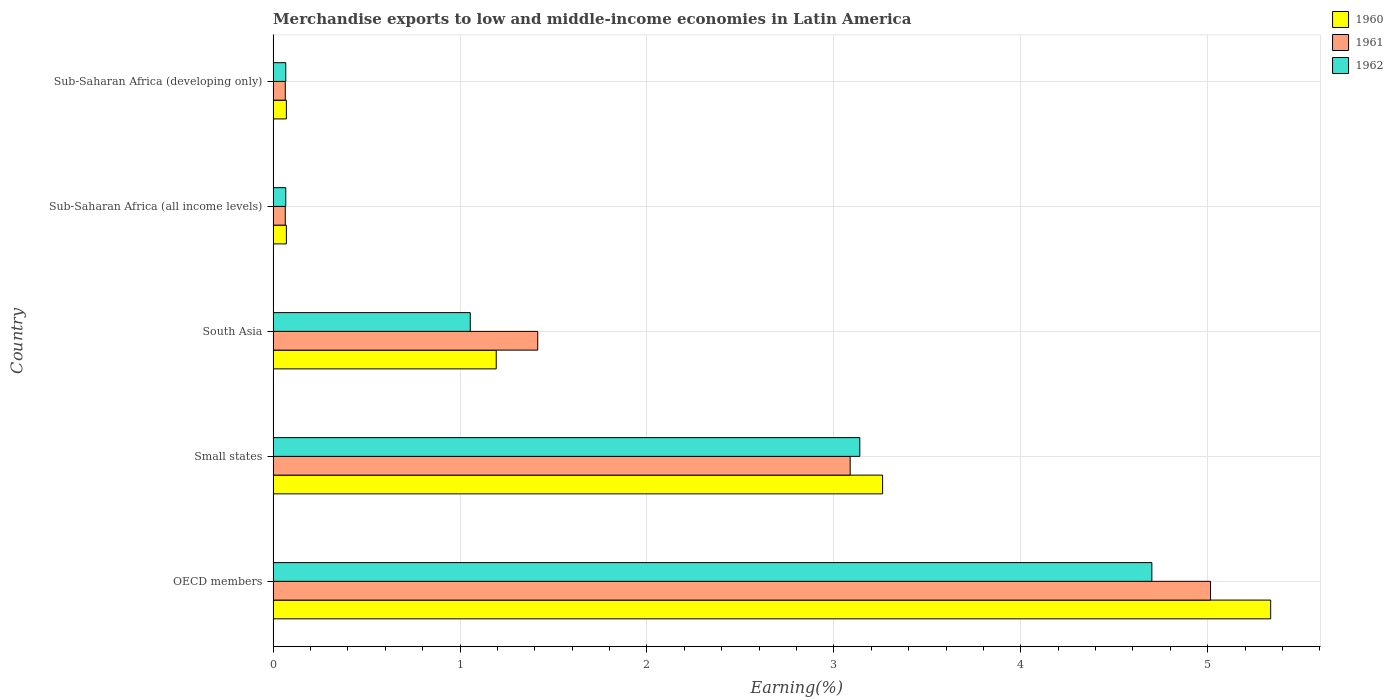How many different coloured bars are there?
Your response must be concise. 3. Are the number of bars per tick equal to the number of legend labels?
Your response must be concise. Yes. Are the number of bars on each tick of the Y-axis equal?
Your answer should be very brief. Yes. How many bars are there on the 4th tick from the top?
Make the answer very short. 3. What is the label of the 2nd group of bars from the top?
Your answer should be compact. Sub-Saharan Africa (all income levels). What is the percentage of amount earned from merchandise exports in 1961 in Small states?
Provide a short and direct response. 3.09. Across all countries, what is the maximum percentage of amount earned from merchandise exports in 1960?
Ensure brevity in your answer.  5.34. Across all countries, what is the minimum percentage of amount earned from merchandise exports in 1962?
Your response must be concise. 0.07. In which country was the percentage of amount earned from merchandise exports in 1962 minimum?
Offer a terse response. Sub-Saharan Africa (all income levels). What is the total percentage of amount earned from merchandise exports in 1961 in the graph?
Provide a short and direct response. 9.65. What is the difference between the percentage of amount earned from merchandise exports in 1961 in OECD members and that in Small states?
Offer a very short reply. 1.93. What is the difference between the percentage of amount earned from merchandise exports in 1962 in Sub-Saharan Africa (developing only) and the percentage of amount earned from merchandise exports in 1961 in Sub-Saharan Africa (all income levels)?
Offer a very short reply. 0. What is the average percentage of amount earned from merchandise exports in 1961 per country?
Provide a short and direct response. 1.93. What is the difference between the percentage of amount earned from merchandise exports in 1960 and percentage of amount earned from merchandise exports in 1961 in South Asia?
Your answer should be compact. -0.22. What is the ratio of the percentage of amount earned from merchandise exports in 1960 in Small states to that in Sub-Saharan Africa (all income levels)?
Ensure brevity in your answer.  46. What is the difference between the highest and the second highest percentage of amount earned from merchandise exports in 1961?
Your answer should be very brief. 1.93. What is the difference between the highest and the lowest percentage of amount earned from merchandise exports in 1961?
Your response must be concise. 4.95. In how many countries, is the percentage of amount earned from merchandise exports in 1961 greater than the average percentage of amount earned from merchandise exports in 1961 taken over all countries?
Your response must be concise. 2. Is the sum of the percentage of amount earned from merchandise exports in 1960 in OECD members and Small states greater than the maximum percentage of amount earned from merchandise exports in 1962 across all countries?
Keep it short and to the point. Yes. What does the 2nd bar from the top in Small states represents?
Your answer should be compact. 1961. Are all the bars in the graph horizontal?
Your answer should be compact. Yes. What is the difference between two consecutive major ticks on the X-axis?
Provide a short and direct response. 1. Are the values on the major ticks of X-axis written in scientific E-notation?
Give a very brief answer. No. Does the graph contain grids?
Provide a short and direct response. Yes. Where does the legend appear in the graph?
Your answer should be compact. Top right. How many legend labels are there?
Your answer should be compact. 3. How are the legend labels stacked?
Give a very brief answer. Vertical. What is the title of the graph?
Your answer should be very brief. Merchandise exports to low and middle-income economies in Latin America. What is the label or title of the X-axis?
Keep it short and to the point. Earning(%). What is the label or title of the Y-axis?
Provide a succinct answer. Country. What is the Earning(%) in 1960 in OECD members?
Make the answer very short. 5.34. What is the Earning(%) of 1961 in OECD members?
Offer a very short reply. 5.02. What is the Earning(%) in 1962 in OECD members?
Make the answer very short. 4.7. What is the Earning(%) in 1960 in Small states?
Give a very brief answer. 3.26. What is the Earning(%) in 1961 in Small states?
Ensure brevity in your answer.  3.09. What is the Earning(%) of 1962 in Small states?
Offer a terse response. 3.14. What is the Earning(%) in 1960 in South Asia?
Keep it short and to the point. 1.19. What is the Earning(%) of 1961 in South Asia?
Give a very brief answer. 1.42. What is the Earning(%) in 1962 in South Asia?
Your response must be concise. 1.05. What is the Earning(%) in 1960 in Sub-Saharan Africa (all income levels)?
Ensure brevity in your answer.  0.07. What is the Earning(%) in 1961 in Sub-Saharan Africa (all income levels)?
Make the answer very short. 0.07. What is the Earning(%) in 1962 in Sub-Saharan Africa (all income levels)?
Offer a terse response. 0.07. What is the Earning(%) of 1960 in Sub-Saharan Africa (developing only)?
Offer a very short reply. 0.07. What is the Earning(%) of 1961 in Sub-Saharan Africa (developing only)?
Keep it short and to the point. 0.07. What is the Earning(%) in 1962 in Sub-Saharan Africa (developing only)?
Keep it short and to the point. 0.07. Across all countries, what is the maximum Earning(%) in 1960?
Provide a succinct answer. 5.34. Across all countries, what is the maximum Earning(%) of 1961?
Offer a very short reply. 5.02. Across all countries, what is the maximum Earning(%) in 1962?
Provide a succinct answer. 4.7. Across all countries, what is the minimum Earning(%) of 1960?
Provide a short and direct response. 0.07. Across all countries, what is the minimum Earning(%) of 1961?
Your answer should be compact. 0.07. Across all countries, what is the minimum Earning(%) of 1962?
Provide a succinct answer. 0.07. What is the total Earning(%) of 1960 in the graph?
Provide a short and direct response. 9.93. What is the total Earning(%) in 1961 in the graph?
Offer a very short reply. 9.65. What is the total Earning(%) of 1962 in the graph?
Your answer should be very brief. 9.03. What is the difference between the Earning(%) of 1960 in OECD members and that in Small states?
Your answer should be compact. 2.08. What is the difference between the Earning(%) of 1961 in OECD members and that in Small states?
Your answer should be very brief. 1.93. What is the difference between the Earning(%) of 1962 in OECD members and that in Small states?
Keep it short and to the point. 1.56. What is the difference between the Earning(%) in 1960 in OECD members and that in South Asia?
Keep it short and to the point. 4.14. What is the difference between the Earning(%) of 1961 in OECD members and that in South Asia?
Provide a succinct answer. 3.6. What is the difference between the Earning(%) of 1962 in OECD members and that in South Asia?
Your response must be concise. 3.65. What is the difference between the Earning(%) of 1960 in OECD members and that in Sub-Saharan Africa (all income levels)?
Ensure brevity in your answer.  5.27. What is the difference between the Earning(%) in 1961 in OECD members and that in Sub-Saharan Africa (all income levels)?
Give a very brief answer. 4.95. What is the difference between the Earning(%) of 1962 in OECD members and that in Sub-Saharan Africa (all income levels)?
Your answer should be very brief. 4.63. What is the difference between the Earning(%) of 1960 in OECD members and that in Sub-Saharan Africa (developing only)?
Keep it short and to the point. 5.27. What is the difference between the Earning(%) of 1961 in OECD members and that in Sub-Saharan Africa (developing only)?
Offer a terse response. 4.95. What is the difference between the Earning(%) of 1962 in OECD members and that in Sub-Saharan Africa (developing only)?
Make the answer very short. 4.63. What is the difference between the Earning(%) in 1960 in Small states and that in South Asia?
Offer a terse response. 2.07. What is the difference between the Earning(%) of 1961 in Small states and that in South Asia?
Ensure brevity in your answer.  1.67. What is the difference between the Earning(%) in 1962 in Small states and that in South Asia?
Your answer should be very brief. 2.08. What is the difference between the Earning(%) in 1960 in Small states and that in Sub-Saharan Africa (all income levels)?
Provide a short and direct response. 3.19. What is the difference between the Earning(%) in 1961 in Small states and that in Sub-Saharan Africa (all income levels)?
Give a very brief answer. 3.02. What is the difference between the Earning(%) of 1962 in Small states and that in Sub-Saharan Africa (all income levels)?
Provide a succinct answer. 3.07. What is the difference between the Earning(%) of 1960 in Small states and that in Sub-Saharan Africa (developing only)?
Ensure brevity in your answer.  3.19. What is the difference between the Earning(%) in 1961 in Small states and that in Sub-Saharan Africa (developing only)?
Ensure brevity in your answer.  3.02. What is the difference between the Earning(%) of 1962 in Small states and that in Sub-Saharan Africa (developing only)?
Ensure brevity in your answer.  3.07. What is the difference between the Earning(%) in 1960 in South Asia and that in Sub-Saharan Africa (all income levels)?
Your response must be concise. 1.12. What is the difference between the Earning(%) of 1961 in South Asia and that in Sub-Saharan Africa (all income levels)?
Make the answer very short. 1.35. What is the difference between the Earning(%) of 1962 in South Asia and that in Sub-Saharan Africa (all income levels)?
Your answer should be compact. 0.99. What is the difference between the Earning(%) of 1960 in South Asia and that in Sub-Saharan Africa (developing only)?
Offer a terse response. 1.12. What is the difference between the Earning(%) in 1961 in South Asia and that in Sub-Saharan Africa (developing only)?
Ensure brevity in your answer.  1.35. What is the difference between the Earning(%) of 1962 in South Asia and that in Sub-Saharan Africa (developing only)?
Your answer should be very brief. 0.99. What is the difference between the Earning(%) of 1961 in Sub-Saharan Africa (all income levels) and that in Sub-Saharan Africa (developing only)?
Offer a very short reply. 0. What is the difference between the Earning(%) of 1962 in Sub-Saharan Africa (all income levels) and that in Sub-Saharan Africa (developing only)?
Keep it short and to the point. 0. What is the difference between the Earning(%) in 1960 in OECD members and the Earning(%) in 1961 in Small states?
Make the answer very short. 2.25. What is the difference between the Earning(%) in 1960 in OECD members and the Earning(%) in 1962 in Small states?
Offer a very short reply. 2.2. What is the difference between the Earning(%) in 1961 in OECD members and the Earning(%) in 1962 in Small states?
Give a very brief answer. 1.88. What is the difference between the Earning(%) in 1960 in OECD members and the Earning(%) in 1961 in South Asia?
Your answer should be very brief. 3.92. What is the difference between the Earning(%) in 1960 in OECD members and the Earning(%) in 1962 in South Asia?
Provide a succinct answer. 4.28. What is the difference between the Earning(%) of 1961 in OECD members and the Earning(%) of 1962 in South Asia?
Your answer should be very brief. 3.96. What is the difference between the Earning(%) in 1960 in OECD members and the Earning(%) in 1961 in Sub-Saharan Africa (all income levels)?
Your answer should be compact. 5.27. What is the difference between the Earning(%) in 1960 in OECD members and the Earning(%) in 1962 in Sub-Saharan Africa (all income levels)?
Provide a succinct answer. 5.27. What is the difference between the Earning(%) in 1961 in OECD members and the Earning(%) in 1962 in Sub-Saharan Africa (all income levels)?
Give a very brief answer. 4.95. What is the difference between the Earning(%) in 1960 in OECD members and the Earning(%) in 1961 in Sub-Saharan Africa (developing only)?
Make the answer very short. 5.27. What is the difference between the Earning(%) of 1960 in OECD members and the Earning(%) of 1962 in Sub-Saharan Africa (developing only)?
Make the answer very short. 5.27. What is the difference between the Earning(%) in 1961 in OECD members and the Earning(%) in 1962 in Sub-Saharan Africa (developing only)?
Offer a very short reply. 4.95. What is the difference between the Earning(%) of 1960 in Small states and the Earning(%) of 1961 in South Asia?
Your answer should be compact. 1.85. What is the difference between the Earning(%) of 1960 in Small states and the Earning(%) of 1962 in South Asia?
Provide a short and direct response. 2.21. What is the difference between the Earning(%) in 1961 in Small states and the Earning(%) in 1962 in South Asia?
Keep it short and to the point. 2.03. What is the difference between the Earning(%) of 1960 in Small states and the Earning(%) of 1961 in Sub-Saharan Africa (all income levels)?
Your answer should be compact. 3.2. What is the difference between the Earning(%) of 1960 in Small states and the Earning(%) of 1962 in Sub-Saharan Africa (all income levels)?
Make the answer very short. 3.19. What is the difference between the Earning(%) of 1961 in Small states and the Earning(%) of 1962 in Sub-Saharan Africa (all income levels)?
Make the answer very short. 3.02. What is the difference between the Earning(%) in 1960 in Small states and the Earning(%) in 1961 in Sub-Saharan Africa (developing only)?
Ensure brevity in your answer.  3.2. What is the difference between the Earning(%) of 1960 in Small states and the Earning(%) of 1962 in Sub-Saharan Africa (developing only)?
Your response must be concise. 3.19. What is the difference between the Earning(%) in 1961 in Small states and the Earning(%) in 1962 in Sub-Saharan Africa (developing only)?
Offer a terse response. 3.02. What is the difference between the Earning(%) in 1960 in South Asia and the Earning(%) in 1961 in Sub-Saharan Africa (all income levels)?
Ensure brevity in your answer.  1.13. What is the difference between the Earning(%) of 1960 in South Asia and the Earning(%) of 1962 in Sub-Saharan Africa (all income levels)?
Keep it short and to the point. 1.13. What is the difference between the Earning(%) in 1961 in South Asia and the Earning(%) in 1962 in Sub-Saharan Africa (all income levels)?
Ensure brevity in your answer.  1.35. What is the difference between the Earning(%) of 1960 in South Asia and the Earning(%) of 1961 in Sub-Saharan Africa (developing only)?
Provide a succinct answer. 1.13. What is the difference between the Earning(%) of 1960 in South Asia and the Earning(%) of 1962 in Sub-Saharan Africa (developing only)?
Provide a succinct answer. 1.13. What is the difference between the Earning(%) of 1961 in South Asia and the Earning(%) of 1962 in Sub-Saharan Africa (developing only)?
Offer a terse response. 1.35. What is the difference between the Earning(%) of 1960 in Sub-Saharan Africa (all income levels) and the Earning(%) of 1961 in Sub-Saharan Africa (developing only)?
Give a very brief answer. 0.01. What is the difference between the Earning(%) of 1960 in Sub-Saharan Africa (all income levels) and the Earning(%) of 1962 in Sub-Saharan Africa (developing only)?
Your response must be concise. 0. What is the difference between the Earning(%) in 1961 in Sub-Saharan Africa (all income levels) and the Earning(%) in 1962 in Sub-Saharan Africa (developing only)?
Offer a terse response. -0. What is the average Earning(%) of 1960 per country?
Provide a succinct answer. 1.99. What is the average Earning(%) of 1961 per country?
Provide a succinct answer. 1.93. What is the average Earning(%) in 1962 per country?
Offer a very short reply. 1.81. What is the difference between the Earning(%) of 1960 and Earning(%) of 1961 in OECD members?
Offer a very short reply. 0.32. What is the difference between the Earning(%) of 1960 and Earning(%) of 1962 in OECD members?
Give a very brief answer. 0.64. What is the difference between the Earning(%) of 1961 and Earning(%) of 1962 in OECD members?
Your response must be concise. 0.31. What is the difference between the Earning(%) in 1960 and Earning(%) in 1961 in Small states?
Provide a short and direct response. 0.17. What is the difference between the Earning(%) in 1960 and Earning(%) in 1962 in Small states?
Your response must be concise. 0.12. What is the difference between the Earning(%) in 1961 and Earning(%) in 1962 in Small states?
Ensure brevity in your answer.  -0.05. What is the difference between the Earning(%) in 1960 and Earning(%) in 1961 in South Asia?
Keep it short and to the point. -0.22. What is the difference between the Earning(%) in 1960 and Earning(%) in 1962 in South Asia?
Provide a short and direct response. 0.14. What is the difference between the Earning(%) in 1961 and Earning(%) in 1962 in South Asia?
Offer a very short reply. 0.36. What is the difference between the Earning(%) of 1960 and Earning(%) of 1961 in Sub-Saharan Africa (all income levels)?
Make the answer very short. 0.01. What is the difference between the Earning(%) of 1960 and Earning(%) of 1962 in Sub-Saharan Africa (all income levels)?
Offer a terse response. 0. What is the difference between the Earning(%) of 1961 and Earning(%) of 1962 in Sub-Saharan Africa (all income levels)?
Make the answer very short. -0. What is the difference between the Earning(%) of 1960 and Earning(%) of 1961 in Sub-Saharan Africa (developing only)?
Keep it short and to the point. 0.01. What is the difference between the Earning(%) in 1960 and Earning(%) in 1962 in Sub-Saharan Africa (developing only)?
Your response must be concise. 0. What is the difference between the Earning(%) in 1961 and Earning(%) in 1962 in Sub-Saharan Africa (developing only)?
Provide a short and direct response. -0. What is the ratio of the Earning(%) in 1960 in OECD members to that in Small states?
Make the answer very short. 1.64. What is the ratio of the Earning(%) in 1961 in OECD members to that in Small states?
Your answer should be compact. 1.62. What is the ratio of the Earning(%) in 1962 in OECD members to that in Small states?
Provide a short and direct response. 1.5. What is the ratio of the Earning(%) of 1960 in OECD members to that in South Asia?
Your answer should be very brief. 4.47. What is the ratio of the Earning(%) in 1961 in OECD members to that in South Asia?
Give a very brief answer. 3.54. What is the ratio of the Earning(%) of 1962 in OECD members to that in South Asia?
Provide a succinct answer. 4.46. What is the ratio of the Earning(%) of 1960 in OECD members to that in Sub-Saharan Africa (all income levels)?
Your answer should be compact. 75.29. What is the ratio of the Earning(%) in 1961 in OECD members to that in Sub-Saharan Africa (all income levels)?
Your answer should be compact. 77.13. What is the ratio of the Earning(%) in 1962 in OECD members to that in Sub-Saharan Africa (all income levels)?
Your response must be concise. 69.48. What is the ratio of the Earning(%) in 1960 in OECD members to that in Sub-Saharan Africa (developing only)?
Provide a succinct answer. 75.29. What is the ratio of the Earning(%) of 1961 in OECD members to that in Sub-Saharan Africa (developing only)?
Give a very brief answer. 77.13. What is the ratio of the Earning(%) of 1962 in OECD members to that in Sub-Saharan Africa (developing only)?
Your response must be concise. 69.48. What is the ratio of the Earning(%) in 1960 in Small states to that in South Asia?
Provide a short and direct response. 2.73. What is the ratio of the Earning(%) in 1961 in Small states to that in South Asia?
Make the answer very short. 2.18. What is the ratio of the Earning(%) in 1962 in Small states to that in South Asia?
Your answer should be very brief. 2.98. What is the ratio of the Earning(%) in 1960 in Small states to that in Sub-Saharan Africa (all income levels)?
Offer a terse response. 46. What is the ratio of the Earning(%) of 1961 in Small states to that in Sub-Saharan Africa (all income levels)?
Offer a terse response. 47.48. What is the ratio of the Earning(%) of 1962 in Small states to that in Sub-Saharan Africa (all income levels)?
Offer a very short reply. 46.39. What is the ratio of the Earning(%) in 1960 in Small states to that in Sub-Saharan Africa (developing only)?
Make the answer very short. 46. What is the ratio of the Earning(%) in 1961 in Small states to that in Sub-Saharan Africa (developing only)?
Offer a terse response. 47.48. What is the ratio of the Earning(%) in 1962 in Small states to that in Sub-Saharan Africa (developing only)?
Offer a very short reply. 46.39. What is the ratio of the Earning(%) of 1960 in South Asia to that in Sub-Saharan Africa (all income levels)?
Your answer should be very brief. 16.84. What is the ratio of the Earning(%) in 1961 in South Asia to that in Sub-Saharan Africa (all income levels)?
Ensure brevity in your answer.  21.77. What is the ratio of the Earning(%) in 1962 in South Asia to that in Sub-Saharan Africa (all income levels)?
Your answer should be compact. 15.59. What is the ratio of the Earning(%) of 1960 in South Asia to that in Sub-Saharan Africa (developing only)?
Your response must be concise. 16.84. What is the ratio of the Earning(%) in 1961 in South Asia to that in Sub-Saharan Africa (developing only)?
Your answer should be compact. 21.77. What is the ratio of the Earning(%) of 1962 in South Asia to that in Sub-Saharan Africa (developing only)?
Keep it short and to the point. 15.59. What is the ratio of the Earning(%) in 1961 in Sub-Saharan Africa (all income levels) to that in Sub-Saharan Africa (developing only)?
Offer a terse response. 1. What is the ratio of the Earning(%) of 1962 in Sub-Saharan Africa (all income levels) to that in Sub-Saharan Africa (developing only)?
Make the answer very short. 1. What is the difference between the highest and the second highest Earning(%) of 1960?
Offer a terse response. 2.08. What is the difference between the highest and the second highest Earning(%) of 1961?
Give a very brief answer. 1.93. What is the difference between the highest and the second highest Earning(%) of 1962?
Provide a short and direct response. 1.56. What is the difference between the highest and the lowest Earning(%) of 1960?
Your response must be concise. 5.27. What is the difference between the highest and the lowest Earning(%) in 1961?
Give a very brief answer. 4.95. What is the difference between the highest and the lowest Earning(%) in 1962?
Provide a short and direct response. 4.63. 